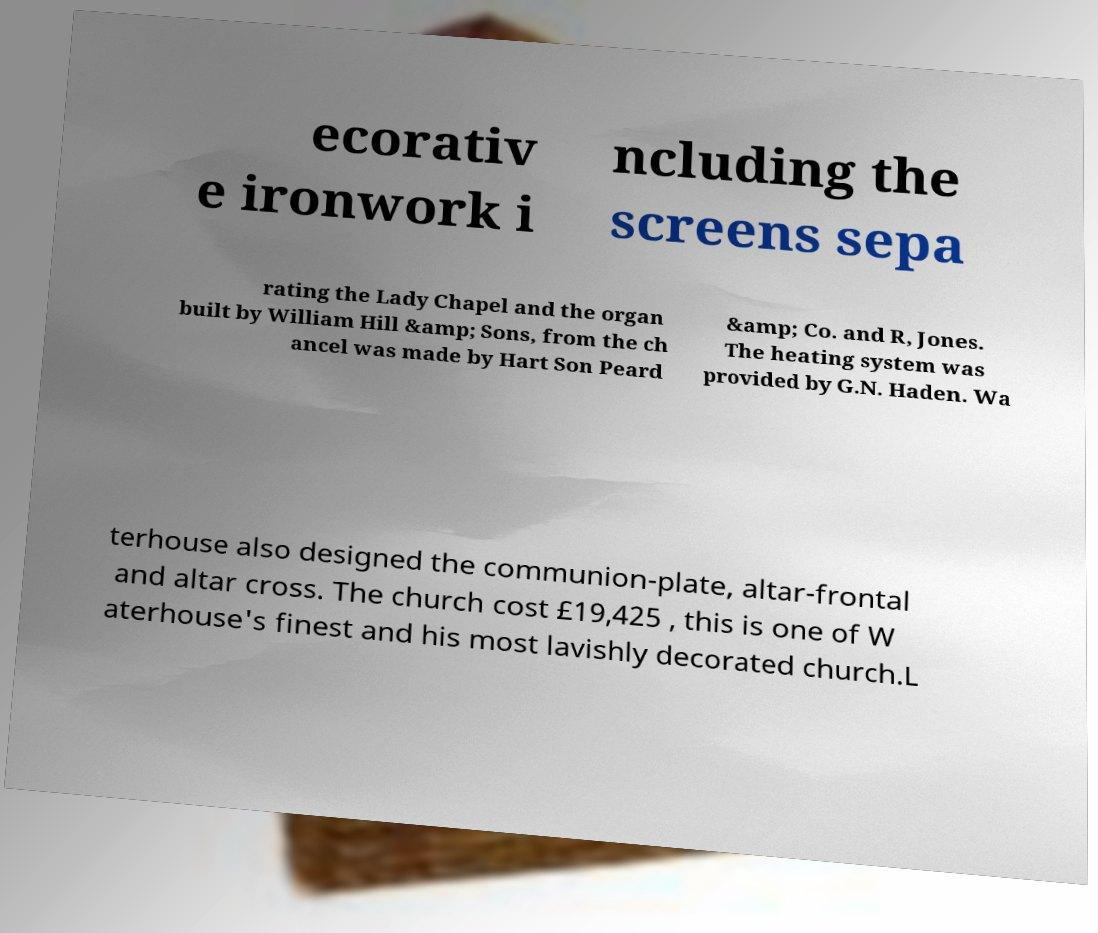Could you extract and type out the text from this image? ecorativ e ironwork i ncluding the screens sepa rating the Lady Chapel and the organ built by William Hill &amp; Sons, from the ch ancel was made by Hart Son Peard &amp; Co. and R, Jones. The heating system was provided by G.N. Haden. Wa terhouse also designed the communion-plate, altar-frontal and altar cross. The church cost £19,425 , this is one of W aterhouse's finest and his most lavishly decorated church.L 